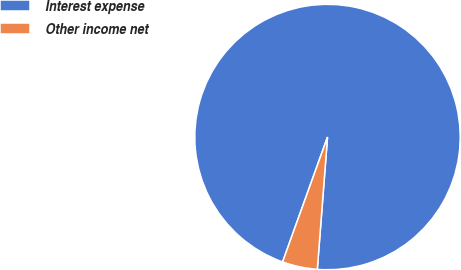Convert chart to OTSL. <chart><loc_0><loc_0><loc_500><loc_500><pie_chart><fcel>Interest expense<fcel>Other income net<nl><fcel>95.73%<fcel>4.27%<nl></chart> 